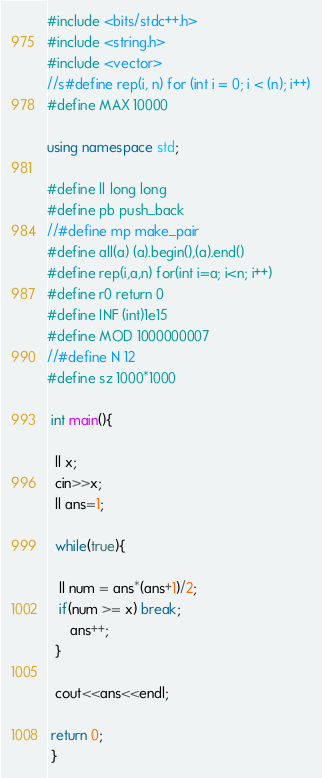Convert code to text. <code><loc_0><loc_0><loc_500><loc_500><_C++_>

#include <bits/stdc++.h>
#include <string.h>
#include <vector>
//s#define rep(i, n) for (int i = 0; i < (n); i++)
#define MAX 10000

using namespace std;

#define ll long long
#define pb push_back
//#define mp make_pair
#define all(a) (a).begin(),(a).end()
#define rep(i,a,n) for(int i=a; i<n; i++)
#define r0 return 0
#define INF (int)1e15
#define MOD 1000000007
//#define N 12
#define sz 1000*1000

 int main(){

  ll x;
  cin>>x;
  ll ans=1;

  while(true){

   ll num = ans*(ans+1)/2;
   if(num >= x) break;
      ans++;
  }

  cout<<ans<<endl;

 return 0;
 }
</code> 